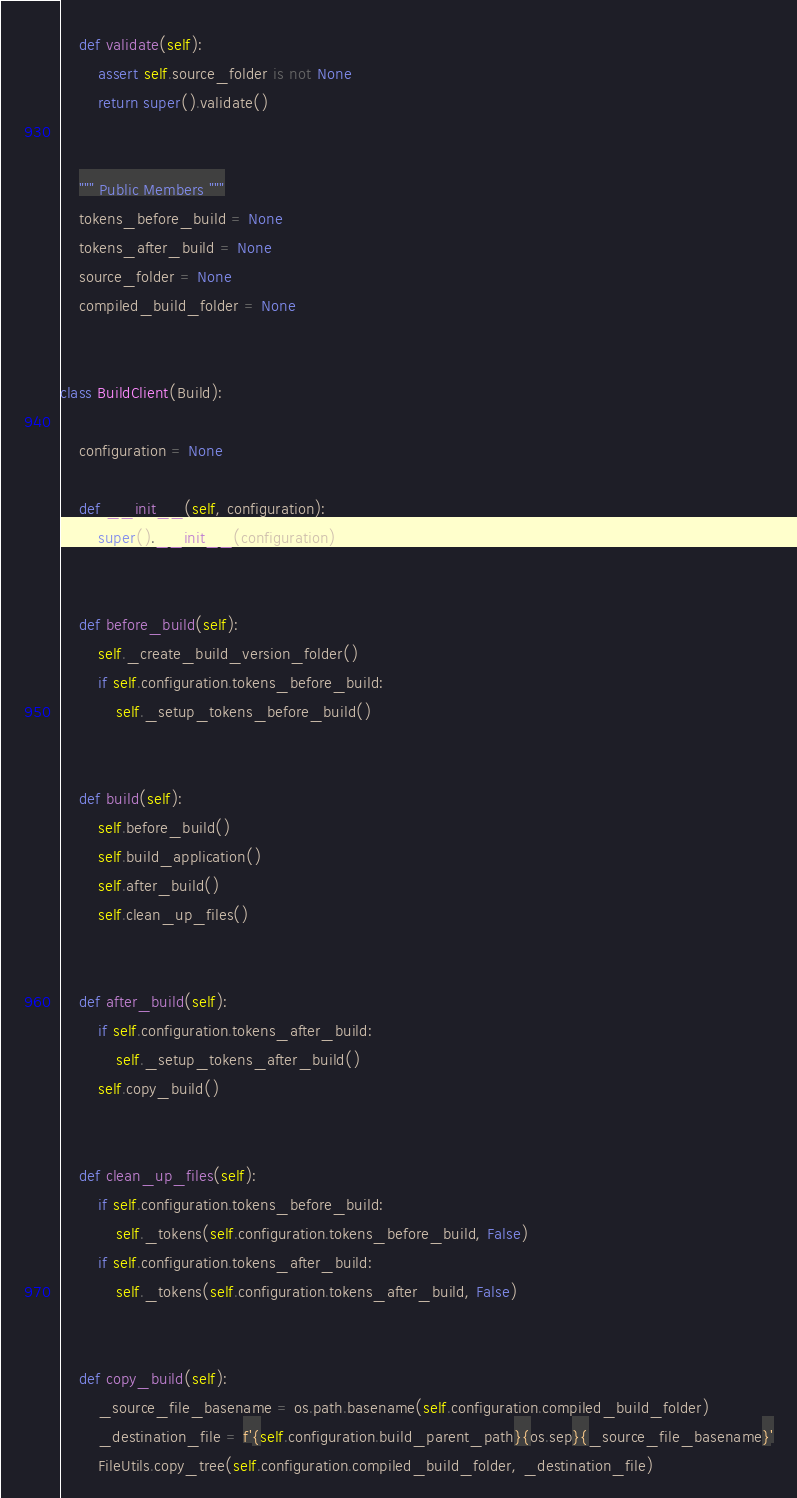<code> <loc_0><loc_0><loc_500><loc_500><_Python_>

    def validate(self):
        assert self.source_folder is not None
        return super().validate()


    """ Public Members """
    tokens_before_build = None
    tokens_after_build = None
    source_folder = None
    compiled_build_folder = None


class BuildClient(Build):

    configuration = None

    def __init__(self, configuration):
        super().__init__(configuration)


    def before_build(self):
        self._create_build_version_folder()
        if self.configuration.tokens_before_build:
            self._setup_tokens_before_build()


    def build(self):
        self.before_build()
        self.build_application()
        self.after_build()
        self.clean_up_files()


    def after_build(self):
        if self.configuration.tokens_after_build:
            self._setup_tokens_after_build()
        self.copy_build()


    def clean_up_files(self):
        if self.configuration.tokens_before_build:
            self._tokens(self.configuration.tokens_before_build, False)
        if self.configuration.tokens_after_build:
            self._tokens(self.configuration.tokens_after_build, False)


    def copy_build(self):
        _source_file_basename = os.path.basename(self.configuration.compiled_build_folder)
        _destination_file = f'{self.configuration.build_parent_path}{os.sep}{_source_file_basename}'
        FileUtils.copy_tree(self.configuration.compiled_build_folder, _destination_file)
</code> 